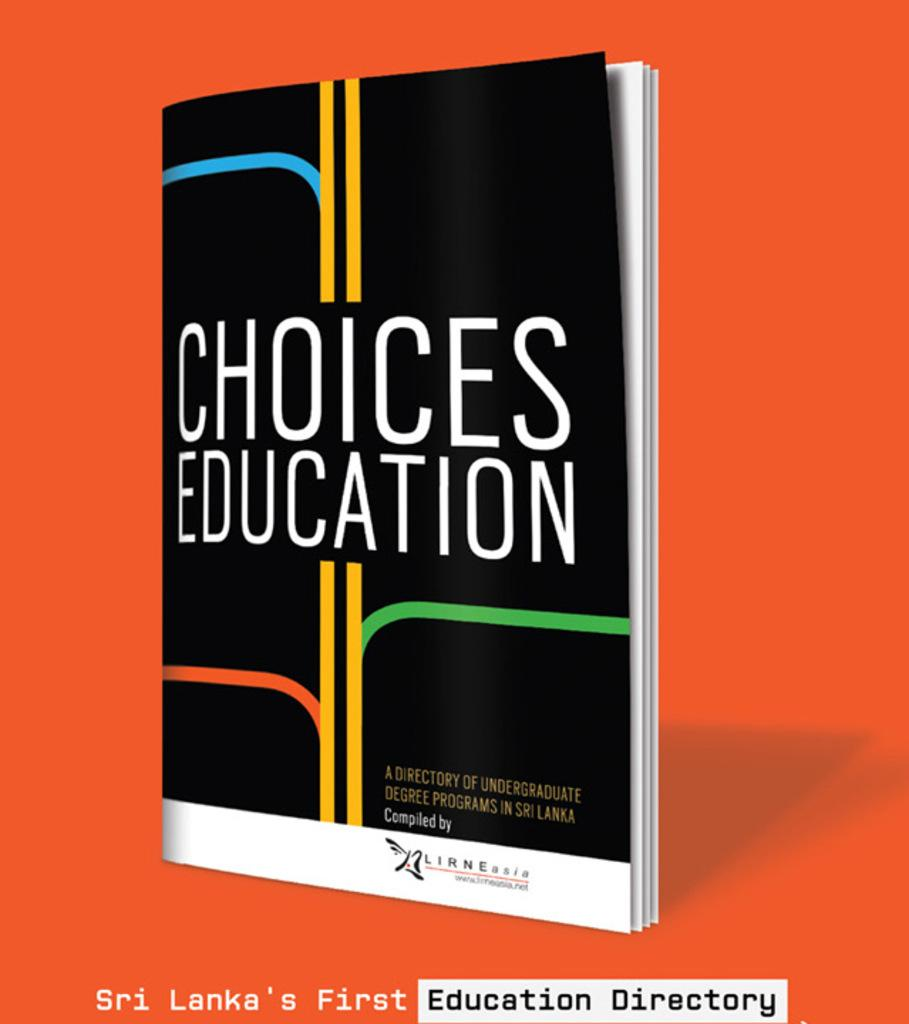<image>
Summarize the visual content of the image. Book cover for Choices Education with yellow lines on it. 